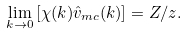<formula> <loc_0><loc_0><loc_500><loc_500>\lim _ { k \to 0 } \left [ \chi ( k ) \hat { v } _ { m c } ( k ) \right ] = Z / z .</formula> 